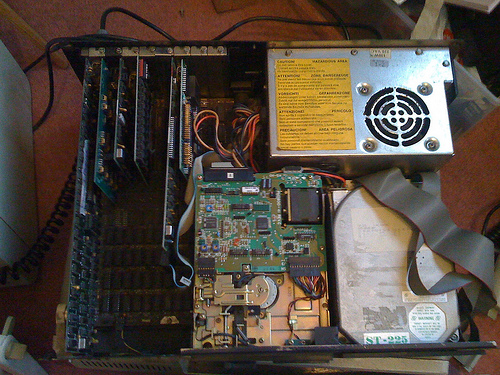<image>
Can you confirm if the computer card is next to the power supply? No. The computer card is not positioned next to the power supply. They are located in different areas of the scene. 